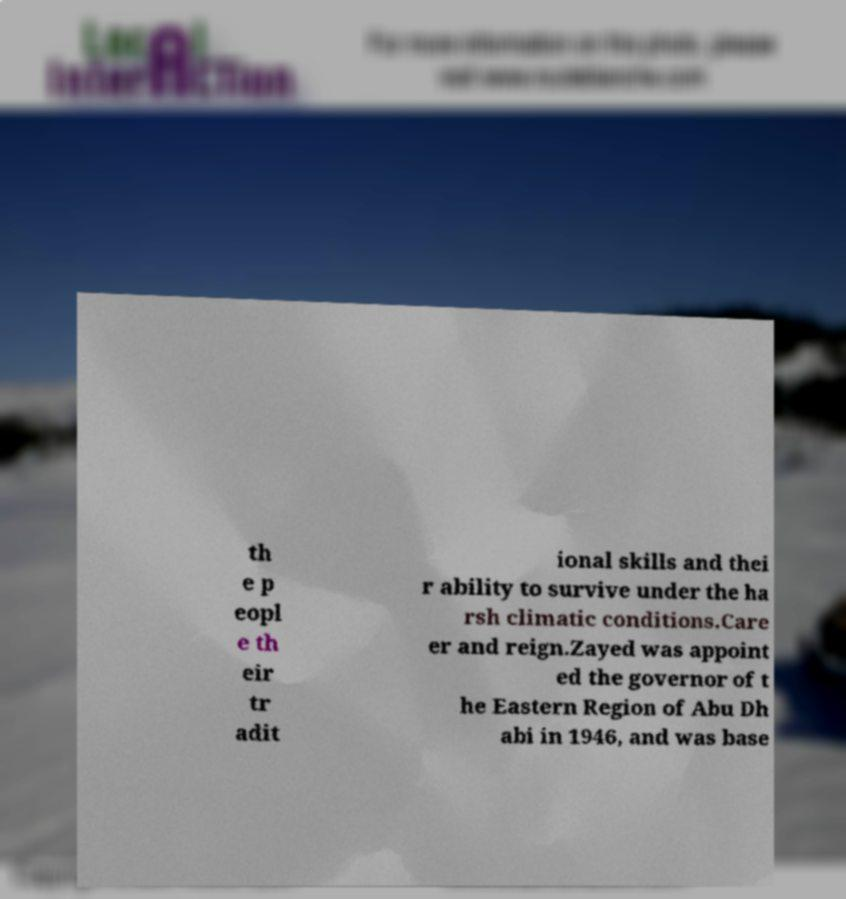I need the written content from this picture converted into text. Can you do that? th e p eopl e th eir tr adit ional skills and thei r ability to survive under the ha rsh climatic conditions.Care er and reign.Zayed was appoint ed the governor of t he Eastern Region of Abu Dh abi in 1946, and was base 